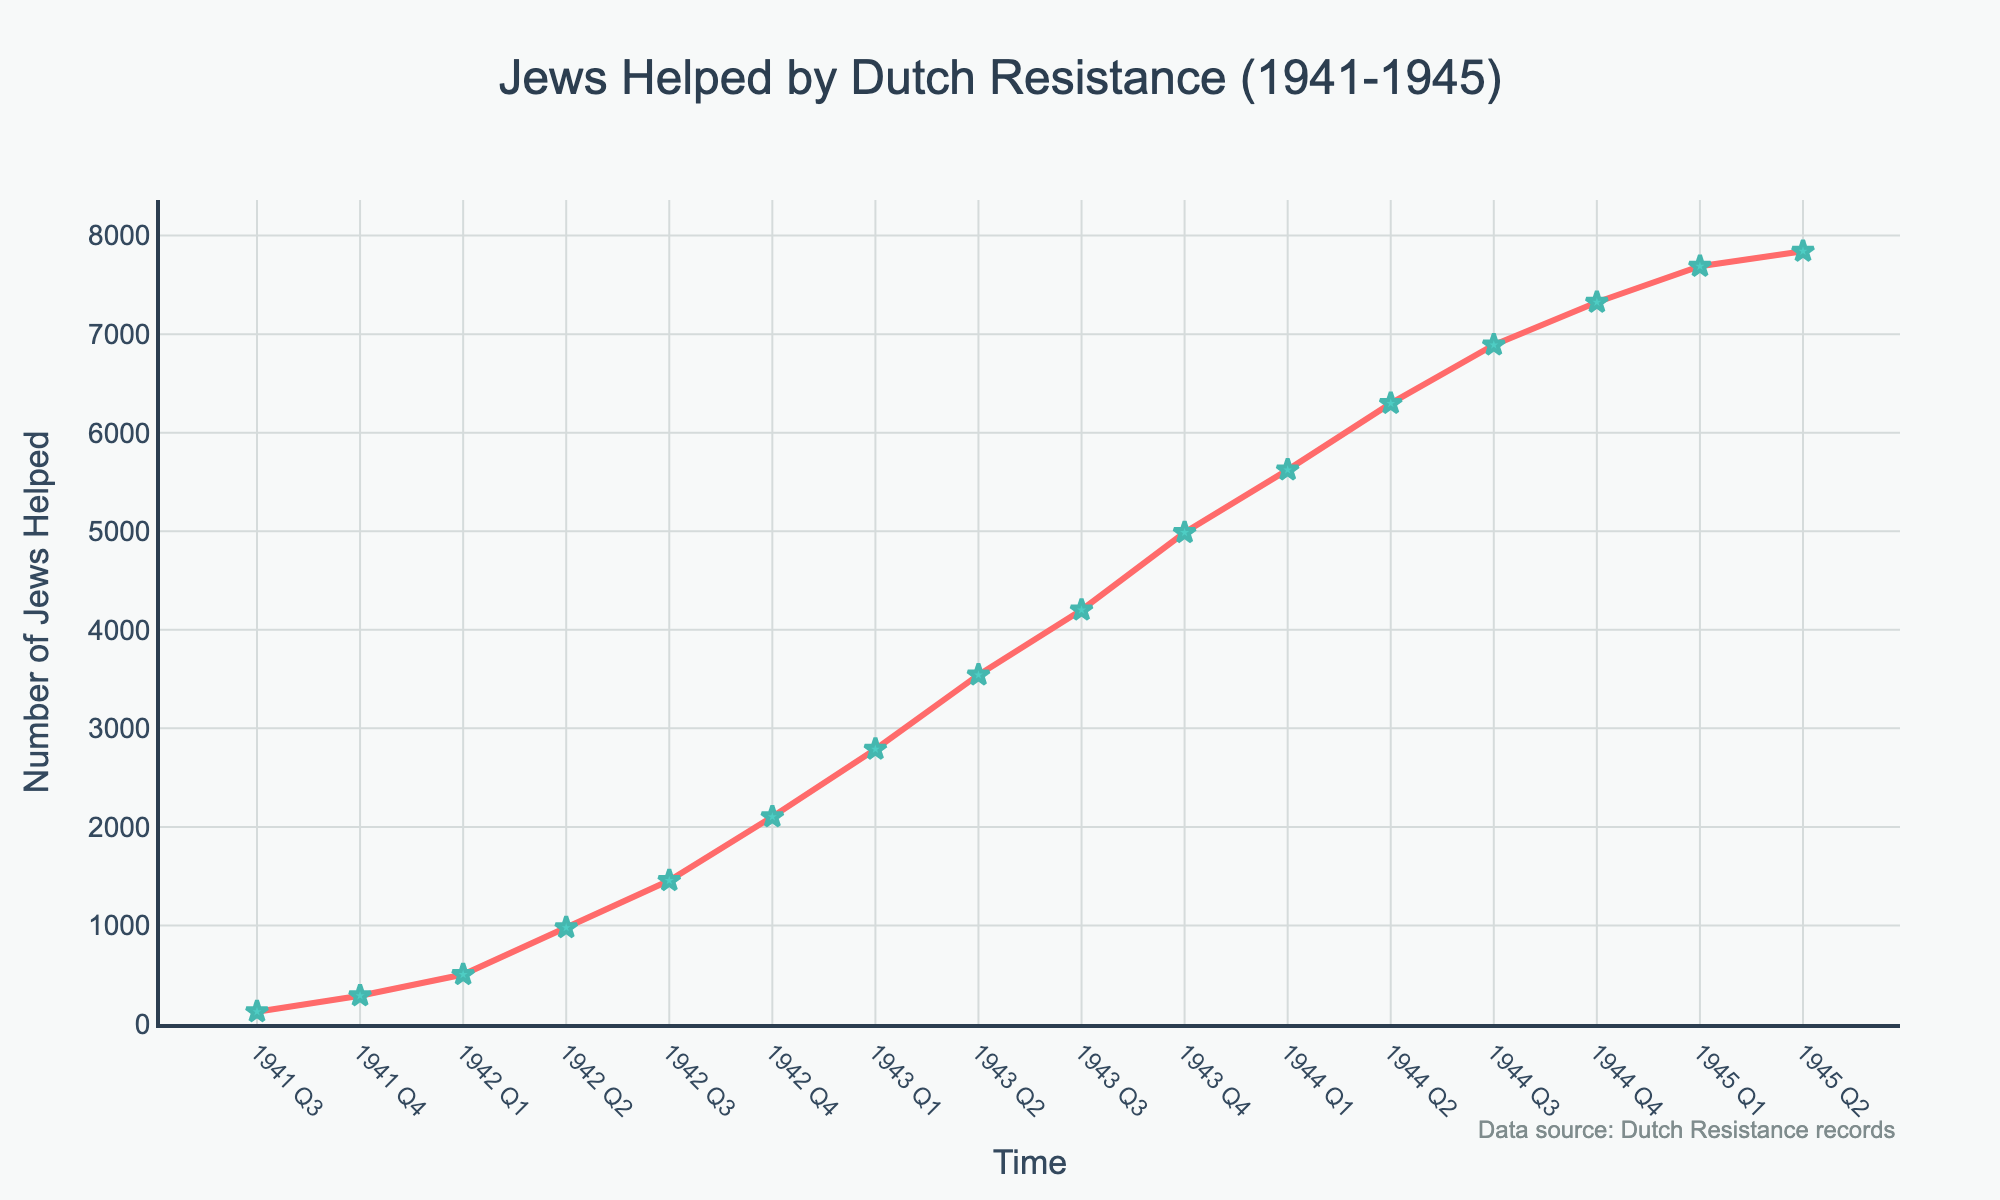what's the general trend in the number of Jews helped from 1941 to 1945? The chart shows the number of Jews helped by the Dutch Resistance increasing each quarter from Q3 1941 to Q2 1945. The numbers rise from 125 in Q3 1941 to 7842 in Q2 1945. This indicates a clear upward trend in the number of Jews being helped.
Answer: Increasing Which quarter saw the highest number of Jews helped? The highest point on the line chart appears in Q2 1945, where the number reaches 7842.
Answer: Q2 1945 How did the number of Jews helped change from the end of 1943 to the end of 1944? At the end of 1943, the number of Jews helped was 4987 in Q4. By the end of 1944, in Q4, it increased to 7324. The change is 7324 - 4987 = 2337.
Answer: Increased by 2337 What is the difference between the number of Jews helped in Q4 1941 and Q1 1942? The number for Q4 1941 is 287 and for Q1 1942 is 502. So, the difference is 502 - 287 = 215.
Answer: 215 In which quarters did the number of Jews helped exceed 5000? Upon inspecting the chart, we see that from Q1 1944 to Q2 1945, the numbers exceed 5000. Specifically, these quarters are Q1 1944 (5623), Q2 1944 (6298), Q3 1944 (6891), Q4 1944 (7324), Q1 1945 (7689), and Q2 1945 (7842).
Answer: Q1 1944, Q2 1944, Q3 1944, Q4 1944, Q1 1945, Q2 1945 How much did the number of Jews helped increase between Q1 1943 and Q2 1943? In Q1 1943, the number was 2789, and in Q2 1943, it was 3542. The increase is 3542 - 2789 = 753.
Answer: 753 Which year saw the largest increase in the number of Jews helped compared to the previous year? By looking at the data, the largest year-over-year increase occurred between 1942 and 1943. The numbers helped at the end of 1942 (Q4) were 2103, and at the end of 1943 (Q4) were 4987. The difference is 4987 - 2103 = 2884.
Answer: Between 1942 and 1943 What is the average number of Jews helped per quarter in 1944? The numbers for each quarter in 1944 are 5623, 6298, 6891, and 7324. Adding these gives 5623 + 6298 + 6891 + 7324 = 26136. Dividing by 4 gives 26136 / 4 = 6534.
Answer: 6534 Compare the increase in the number of Jews helped from 1941 Q4 to 1942 Q4 with the increase from 1943 Q4 to 1944 Q4. Which period had the larger increase? From Q4 1941 (287) to Q4 1942 (2103), the increase is 2103 - 287 = 1816. From Q4 1943 (4987) to Q4 1944 (7324), the increase is 7324 - 4987 = 2337. Thus, the increase from Q4 1943 to Q4 1944 is larger.
Answer: Q4 1943 to Q4 1944 